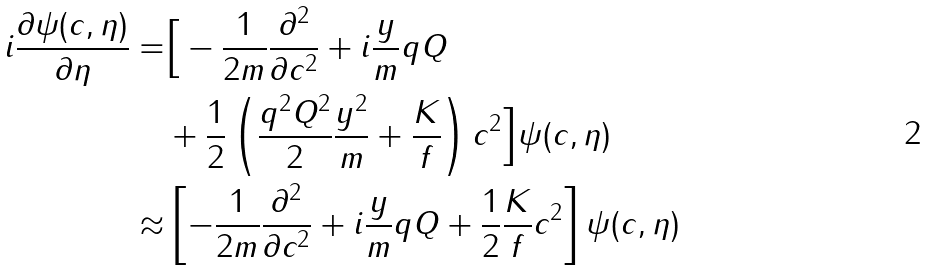Convert formula to latex. <formula><loc_0><loc_0><loc_500><loc_500>i \frac { \partial \psi ( c , \eta ) } { \partial \eta } = & \Big { [ } - \frac { 1 } { 2 m } \frac { \partial ^ { 2 } } { \partial c ^ { 2 } } + i \frac { y } { m } q Q \\ & + \frac { 1 } { 2 } \left ( \frac { q ^ { 2 } Q ^ { 2 } } { 2 } \frac { y ^ { 2 } } { m } + \frac { K } { f } \right ) c ^ { 2 } \Big { ] } \psi ( c , \eta ) \\ \approx & \left [ - \frac { 1 } { 2 m } \frac { \partial ^ { 2 } } { \partial c ^ { 2 } } + i \frac { y } { m } q Q + \frac { 1 } { 2 } \frac { K } { f } c ^ { 2 } \right ] \psi ( c , \eta )</formula> 